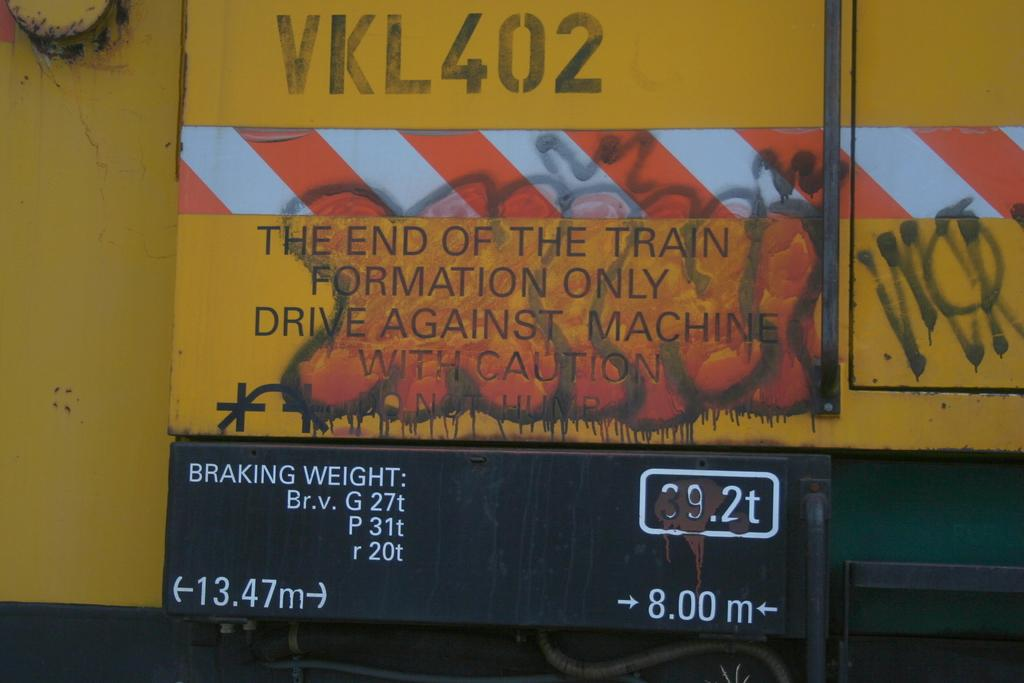Provide a one-sentence caption for the provided image. A sign with VKL402 is displayed on the end of a train. 